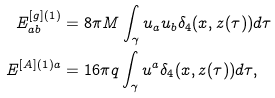Convert formula to latex. <formula><loc_0><loc_0><loc_500><loc_500>E ^ { [ g ] ( 1 ) } _ { a b } & = 8 \pi M \int _ { \gamma } u _ { a } u _ { b } \delta _ { 4 } ( x , z ( \tau ) ) d \tau \\ E ^ { [ A ] ( 1 ) a } & = 1 6 \pi q \int _ { \gamma } u ^ { a } \delta _ { 4 } ( x , z ( \tau ) ) d \tau ,</formula> 